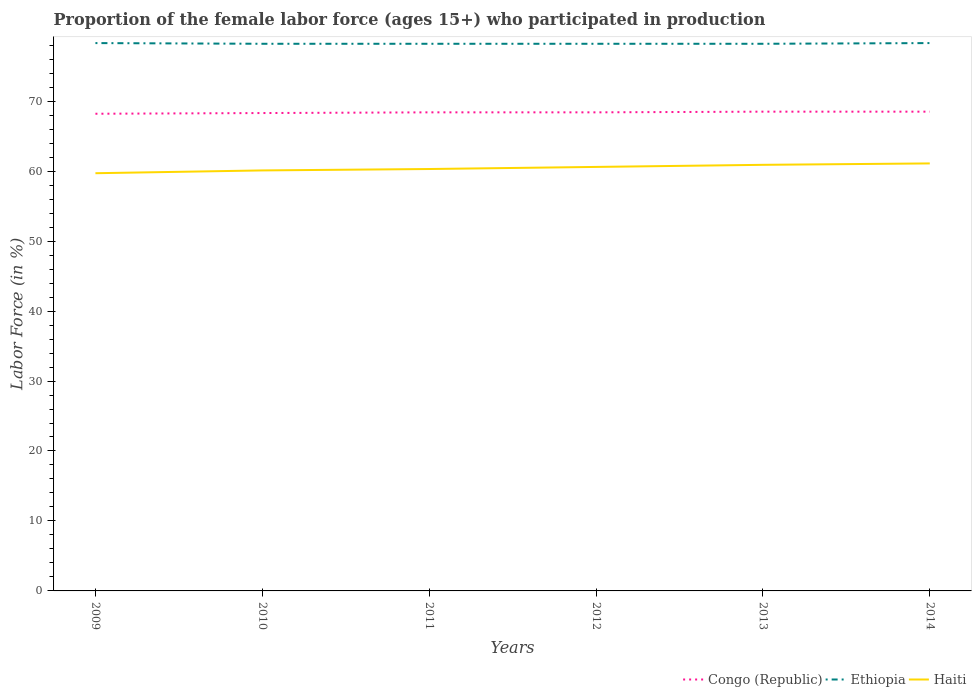How many different coloured lines are there?
Give a very brief answer. 3. Does the line corresponding to Haiti intersect with the line corresponding to Congo (Republic)?
Your response must be concise. No. Across all years, what is the maximum proportion of the female labor force who participated in production in Haiti?
Provide a succinct answer. 59.7. In which year was the proportion of the female labor force who participated in production in Ethiopia maximum?
Your answer should be very brief. 2010. What is the total proportion of the female labor force who participated in production in Haiti in the graph?
Ensure brevity in your answer.  -0.2. What is the difference between the highest and the second highest proportion of the female labor force who participated in production in Haiti?
Ensure brevity in your answer.  1.4. What is the difference between the highest and the lowest proportion of the female labor force who participated in production in Ethiopia?
Your response must be concise. 2. Is the proportion of the female labor force who participated in production in Haiti strictly greater than the proportion of the female labor force who participated in production in Congo (Republic) over the years?
Offer a terse response. Yes. Does the graph contain any zero values?
Offer a very short reply. No. Does the graph contain grids?
Provide a short and direct response. No. Where does the legend appear in the graph?
Provide a short and direct response. Bottom right. How many legend labels are there?
Offer a terse response. 3. What is the title of the graph?
Provide a short and direct response. Proportion of the female labor force (ages 15+) who participated in production. Does "Northern Mariana Islands" appear as one of the legend labels in the graph?
Your answer should be compact. No. What is the label or title of the X-axis?
Offer a very short reply. Years. What is the label or title of the Y-axis?
Give a very brief answer. Labor Force (in %). What is the Labor Force (in %) in Congo (Republic) in 2009?
Your answer should be very brief. 68.2. What is the Labor Force (in %) of Ethiopia in 2009?
Offer a very short reply. 78.3. What is the Labor Force (in %) of Haiti in 2009?
Your response must be concise. 59.7. What is the Labor Force (in %) of Congo (Republic) in 2010?
Your answer should be very brief. 68.3. What is the Labor Force (in %) in Ethiopia in 2010?
Provide a short and direct response. 78.2. What is the Labor Force (in %) of Haiti in 2010?
Offer a very short reply. 60.1. What is the Labor Force (in %) in Congo (Republic) in 2011?
Offer a very short reply. 68.4. What is the Labor Force (in %) of Ethiopia in 2011?
Offer a terse response. 78.2. What is the Labor Force (in %) in Haiti in 2011?
Your answer should be very brief. 60.3. What is the Labor Force (in %) of Congo (Republic) in 2012?
Provide a short and direct response. 68.4. What is the Labor Force (in %) in Ethiopia in 2012?
Your answer should be compact. 78.2. What is the Labor Force (in %) of Haiti in 2012?
Your answer should be very brief. 60.6. What is the Labor Force (in %) of Congo (Republic) in 2013?
Provide a succinct answer. 68.5. What is the Labor Force (in %) of Ethiopia in 2013?
Your response must be concise. 78.2. What is the Labor Force (in %) of Haiti in 2013?
Ensure brevity in your answer.  60.9. What is the Labor Force (in %) in Congo (Republic) in 2014?
Your response must be concise. 68.5. What is the Labor Force (in %) of Ethiopia in 2014?
Your answer should be very brief. 78.3. What is the Labor Force (in %) of Haiti in 2014?
Offer a very short reply. 61.1. Across all years, what is the maximum Labor Force (in %) in Congo (Republic)?
Ensure brevity in your answer.  68.5. Across all years, what is the maximum Labor Force (in %) in Ethiopia?
Offer a very short reply. 78.3. Across all years, what is the maximum Labor Force (in %) of Haiti?
Provide a short and direct response. 61.1. Across all years, what is the minimum Labor Force (in %) of Congo (Republic)?
Provide a short and direct response. 68.2. Across all years, what is the minimum Labor Force (in %) of Ethiopia?
Keep it short and to the point. 78.2. Across all years, what is the minimum Labor Force (in %) of Haiti?
Your answer should be very brief. 59.7. What is the total Labor Force (in %) in Congo (Republic) in the graph?
Provide a short and direct response. 410.3. What is the total Labor Force (in %) in Ethiopia in the graph?
Your answer should be very brief. 469.4. What is the total Labor Force (in %) in Haiti in the graph?
Offer a very short reply. 362.7. What is the difference between the Labor Force (in %) of Congo (Republic) in 2009 and that in 2010?
Your answer should be very brief. -0.1. What is the difference between the Labor Force (in %) in Ethiopia in 2009 and that in 2010?
Ensure brevity in your answer.  0.1. What is the difference between the Labor Force (in %) in Ethiopia in 2009 and that in 2011?
Give a very brief answer. 0.1. What is the difference between the Labor Force (in %) of Congo (Republic) in 2009 and that in 2012?
Offer a terse response. -0.2. What is the difference between the Labor Force (in %) of Ethiopia in 2009 and that in 2012?
Give a very brief answer. 0.1. What is the difference between the Labor Force (in %) in Haiti in 2009 and that in 2012?
Offer a terse response. -0.9. What is the difference between the Labor Force (in %) in Haiti in 2009 and that in 2013?
Provide a short and direct response. -1.2. What is the difference between the Labor Force (in %) in Congo (Republic) in 2009 and that in 2014?
Keep it short and to the point. -0.3. What is the difference between the Labor Force (in %) of Ethiopia in 2009 and that in 2014?
Your answer should be compact. 0. What is the difference between the Labor Force (in %) in Congo (Republic) in 2010 and that in 2011?
Your answer should be compact. -0.1. What is the difference between the Labor Force (in %) in Ethiopia in 2010 and that in 2011?
Your answer should be compact. 0. What is the difference between the Labor Force (in %) in Haiti in 2010 and that in 2012?
Offer a very short reply. -0.5. What is the difference between the Labor Force (in %) of Congo (Republic) in 2010 and that in 2013?
Make the answer very short. -0.2. What is the difference between the Labor Force (in %) in Ethiopia in 2010 and that in 2013?
Make the answer very short. 0. What is the difference between the Labor Force (in %) of Haiti in 2010 and that in 2013?
Offer a terse response. -0.8. What is the difference between the Labor Force (in %) in Congo (Republic) in 2010 and that in 2014?
Provide a short and direct response. -0.2. What is the difference between the Labor Force (in %) of Congo (Republic) in 2011 and that in 2012?
Offer a terse response. 0. What is the difference between the Labor Force (in %) of Ethiopia in 2011 and that in 2012?
Provide a succinct answer. 0. What is the difference between the Labor Force (in %) in Haiti in 2011 and that in 2012?
Offer a terse response. -0.3. What is the difference between the Labor Force (in %) in Haiti in 2011 and that in 2013?
Offer a very short reply. -0.6. What is the difference between the Labor Force (in %) in Congo (Republic) in 2011 and that in 2014?
Keep it short and to the point. -0.1. What is the difference between the Labor Force (in %) of Ethiopia in 2011 and that in 2014?
Your response must be concise. -0.1. What is the difference between the Labor Force (in %) in Ethiopia in 2012 and that in 2013?
Your response must be concise. 0. What is the difference between the Labor Force (in %) in Haiti in 2012 and that in 2013?
Make the answer very short. -0.3. What is the difference between the Labor Force (in %) in Haiti in 2012 and that in 2014?
Give a very brief answer. -0.5. What is the difference between the Labor Force (in %) of Congo (Republic) in 2013 and that in 2014?
Make the answer very short. 0. What is the difference between the Labor Force (in %) in Congo (Republic) in 2009 and the Labor Force (in %) in Ethiopia in 2010?
Keep it short and to the point. -10. What is the difference between the Labor Force (in %) in Congo (Republic) in 2009 and the Labor Force (in %) in Haiti in 2010?
Make the answer very short. 8.1. What is the difference between the Labor Force (in %) of Ethiopia in 2009 and the Labor Force (in %) of Haiti in 2010?
Offer a very short reply. 18.2. What is the difference between the Labor Force (in %) of Congo (Republic) in 2009 and the Labor Force (in %) of Haiti in 2011?
Provide a short and direct response. 7.9. What is the difference between the Labor Force (in %) in Ethiopia in 2009 and the Labor Force (in %) in Haiti in 2011?
Make the answer very short. 18. What is the difference between the Labor Force (in %) of Ethiopia in 2009 and the Labor Force (in %) of Haiti in 2012?
Provide a short and direct response. 17.7. What is the difference between the Labor Force (in %) in Congo (Republic) in 2009 and the Labor Force (in %) in Ethiopia in 2013?
Ensure brevity in your answer.  -10. What is the difference between the Labor Force (in %) in Congo (Republic) in 2009 and the Labor Force (in %) in Haiti in 2013?
Give a very brief answer. 7.3. What is the difference between the Labor Force (in %) in Ethiopia in 2009 and the Labor Force (in %) in Haiti in 2013?
Ensure brevity in your answer.  17.4. What is the difference between the Labor Force (in %) of Congo (Republic) in 2009 and the Labor Force (in %) of Ethiopia in 2014?
Your answer should be very brief. -10.1. What is the difference between the Labor Force (in %) of Congo (Republic) in 2009 and the Labor Force (in %) of Haiti in 2014?
Give a very brief answer. 7.1. What is the difference between the Labor Force (in %) in Congo (Republic) in 2010 and the Labor Force (in %) in Ethiopia in 2011?
Give a very brief answer. -9.9. What is the difference between the Labor Force (in %) of Ethiopia in 2010 and the Labor Force (in %) of Haiti in 2011?
Your answer should be very brief. 17.9. What is the difference between the Labor Force (in %) in Congo (Republic) in 2010 and the Labor Force (in %) in Ethiopia in 2012?
Your answer should be very brief. -9.9. What is the difference between the Labor Force (in %) in Congo (Republic) in 2010 and the Labor Force (in %) in Haiti in 2012?
Offer a terse response. 7.7. What is the difference between the Labor Force (in %) of Congo (Republic) in 2010 and the Labor Force (in %) of Ethiopia in 2013?
Your response must be concise. -9.9. What is the difference between the Labor Force (in %) of Congo (Republic) in 2010 and the Labor Force (in %) of Haiti in 2013?
Provide a short and direct response. 7.4. What is the difference between the Labor Force (in %) in Ethiopia in 2010 and the Labor Force (in %) in Haiti in 2013?
Your answer should be compact. 17.3. What is the difference between the Labor Force (in %) of Congo (Republic) in 2011 and the Labor Force (in %) of Haiti in 2012?
Provide a succinct answer. 7.8. What is the difference between the Labor Force (in %) in Congo (Republic) in 2011 and the Labor Force (in %) in Haiti in 2013?
Your response must be concise. 7.5. What is the difference between the Labor Force (in %) of Congo (Republic) in 2011 and the Labor Force (in %) of Haiti in 2014?
Keep it short and to the point. 7.3. What is the difference between the Labor Force (in %) in Ethiopia in 2011 and the Labor Force (in %) in Haiti in 2014?
Offer a very short reply. 17.1. What is the difference between the Labor Force (in %) of Congo (Republic) in 2012 and the Labor Force (in %) of Haiti in 2013?
Ensure brevity in your answer.  7.5. What is the difference between the Labor Force (in %) in Ethiopia in 2012 and the Labor Force (in %) in Haiti in 2013?
Your response must be concise. 17.3. What is the difference between the Labor Force (in %) of Congo (Republic) in 2012 and the Labor Force (in %) of Ethiopia in 2014?
Your answer should be compact. -9.9. What is the difference between the Labor Force (in %) in Congo (Republic) in 2012 and the Labor Force (in %) in Haiti in 2014?
Ensure brevity in your answer.  7.3. What is the difference between the Labor Force (in %) in Ethiopia in 2012 and the Labor Force (in %) in Haiti in 2014?
Provide a succinct answer. 17.1. What is the difference between the Labor Force (in %) in Congo (Republic) in 2013 and the Labor Force (in %) in Haiti in 2014?
Make the answer very short. 7.4. What is the average Labor Force (in %) in Congo (Republic) per year?
Offer a terse response. 68.38. What is the average Labor Force (in %) of Ethiopia per year?
Give a very brief answer. 78.23. What is the average Labor Force (in %) in Haiti per year?
Make the answer very short. 60.45. In the year 2009, what is the difference between the Labor Force (in %) in Ethiopia and Labor Force (in %) in Haiti?
Offer a terse response. 18.6. In the year 2010, what is the difference between the Labor Force (in %) of Congo (Republic) and Labor Force (in %) of Ethiopia?
Provide a short and direct response. -9.9. In the year 2010, what is the difference between the Labor Force (in %) in Ethiopia and Labor Force (in %) in Haiti?
Offer a very short reply. 18.1. In the year 2011, what is the difference between the Labor Force (in %) of Ethiopia and Labor Force (in %) of Haiti?
Provide a succinct answer. 17.9. In the year 2013, what is the difference between the Labor Force (in %) of Congo (Republic) and Labor Force (in %) of Ethiopia?
Your answer should be compact. -9.7. In the year 2013, what is the difference between the Labor Force (in %) of Congo (Republic) and Labor Force (in %) of Haiti?
Make the answer very short. 7.6. In the year 2013, what is the difference between the Labor Force (in %) of Ethiopia and Labor Force (in %) of Haiti?
Give a very brief answer. 17.3. What is the ratio of the Labor Force (in %) in Congo (Republic) in 2009 to that in 2010?
Offer a terse response. 1. What is the ratio of the Labor Force (in %) of Ethiopia in 2009 to that in 2010?
Keep it short and to the point. 1. What is the ratio of the Labor Force (in %) in Congo (Republic) in 2009 to that in 2011?
Keep it short and to the point. 1. What is the ratio of the Labor Force (in %) of Ethiopia in 2009 to that in 2011?
Offer a very short reply. 1. What is the ratio of the Labor Force (in %) of Congo (Republic) in 2009 to that in 2012?
Ensure brevity in your answer.  1. What is the ratio of the Labor Force (in %) in Ethiopia in 2009 to that in 2012?
Give a very brief answer. 1. What is the ratio of the Labor Force (in %) in Haiti in 2009 to that in 2012?
Ensure brevity in your answer.  0.99. What is the ratio of the Labor Force (in %) in Ethiopia in 2009 to that in 2013?
Provide a short and direct response. 1. What is the ratio of the Labor Force (in %) of Haiti in 2009 to that in 2013?
Provide a succinct answer. 0.98. What is the ratio of the Labor Force (in %) of Ethiopia in 2009 to that in 2014?
Your response must be concise. 1. What is the ratio of the Labor Force (in %) of Haiti in 2009 to that in 2014?
Your answer should be very brief. 0.98. What is the ratio of the Labor Force (in %) in Haiti in 2010 to that in 2012?
Offer a terse response. 0.99. What is the ratio of the Labor Force (in %) in Congo (Republic) in 2010 to that in 2013?
Your answer should be very brief. 1. What is the ratio of the Labor Force (in %) of Haiti in 2010 to that in 2013?
Offer a terse response. 0.99. What is the ratio of the Labor Force (in %) of Congo (Republic) in 2010 to that in 2014?
Offer a terse response. 1. What is the ratio of the Labor Force (in %) of Ethiopia in 2010 to that in 2014?
Your answer should be compact. 1. What is the ratio of the Labor Force (in %) in Haiti in 2010 to that in 2014?
Give a very brief answer. 0.98. What is the ratio of the Labor Force (in %) of Haiti in 2011 to that in 2012?
Your answer should be very brief. 0.99. What is the ratio of the Labor Force (in %) of Congo (Republic) in 2011 to that in 2013?
Your answer should be very brief. 1. What is the ratio of the Labor Force (in %) of Ethiopia in 2011 to that in 2013?
Your answer should be compact. 1. What is the ratio of the Labor Force (in %) of Haiti in 2011 to that in 2013?
Provide a succinct answer. 0.99. What is the ratio of the Labor Force (in %) in Congo (Republic) in 2011 to that in 2014?
Offer a very short reply. 1. What is the ratio of the Labor Force (in %) in Haiti in 2011 to that in 2014?
Your answer should be compact. 0.99. What is the ratio of the Labor Force (in %) of Haiti in 2012 to that in 2013?
Give a very brief answer. 1. What is the ratio of the Labor Force (in %) in Congo (Republic) in 2012 to that in 2014?
Provide a succinct answer. 1. What is the ratio of the Labor Force (in %) in Haiti in 2013 to that in 2014?
Ensure brevity in your answer.  1. What is the difference between the highest and the second highest Labor Force (in %) in Congo (Republic)?
Your answer should be compact. 0. What is the difference between the highest and the second highest Labor Force (in %) in Ethiopia?
Your response must be concise. 0. What is the difference between the highest and the second highest Labor Force (in %) in Haiti?
Ensure brevity in your answer.  0.2. What is the difference between the highest and the lowest Labor Force (in %) in Ethiopia?
Keep it short and to the point. 0.1. What is the difference between the highest and the lowest Labor Force (in %) of Haiti?
Your response must be concise. 1.4. 